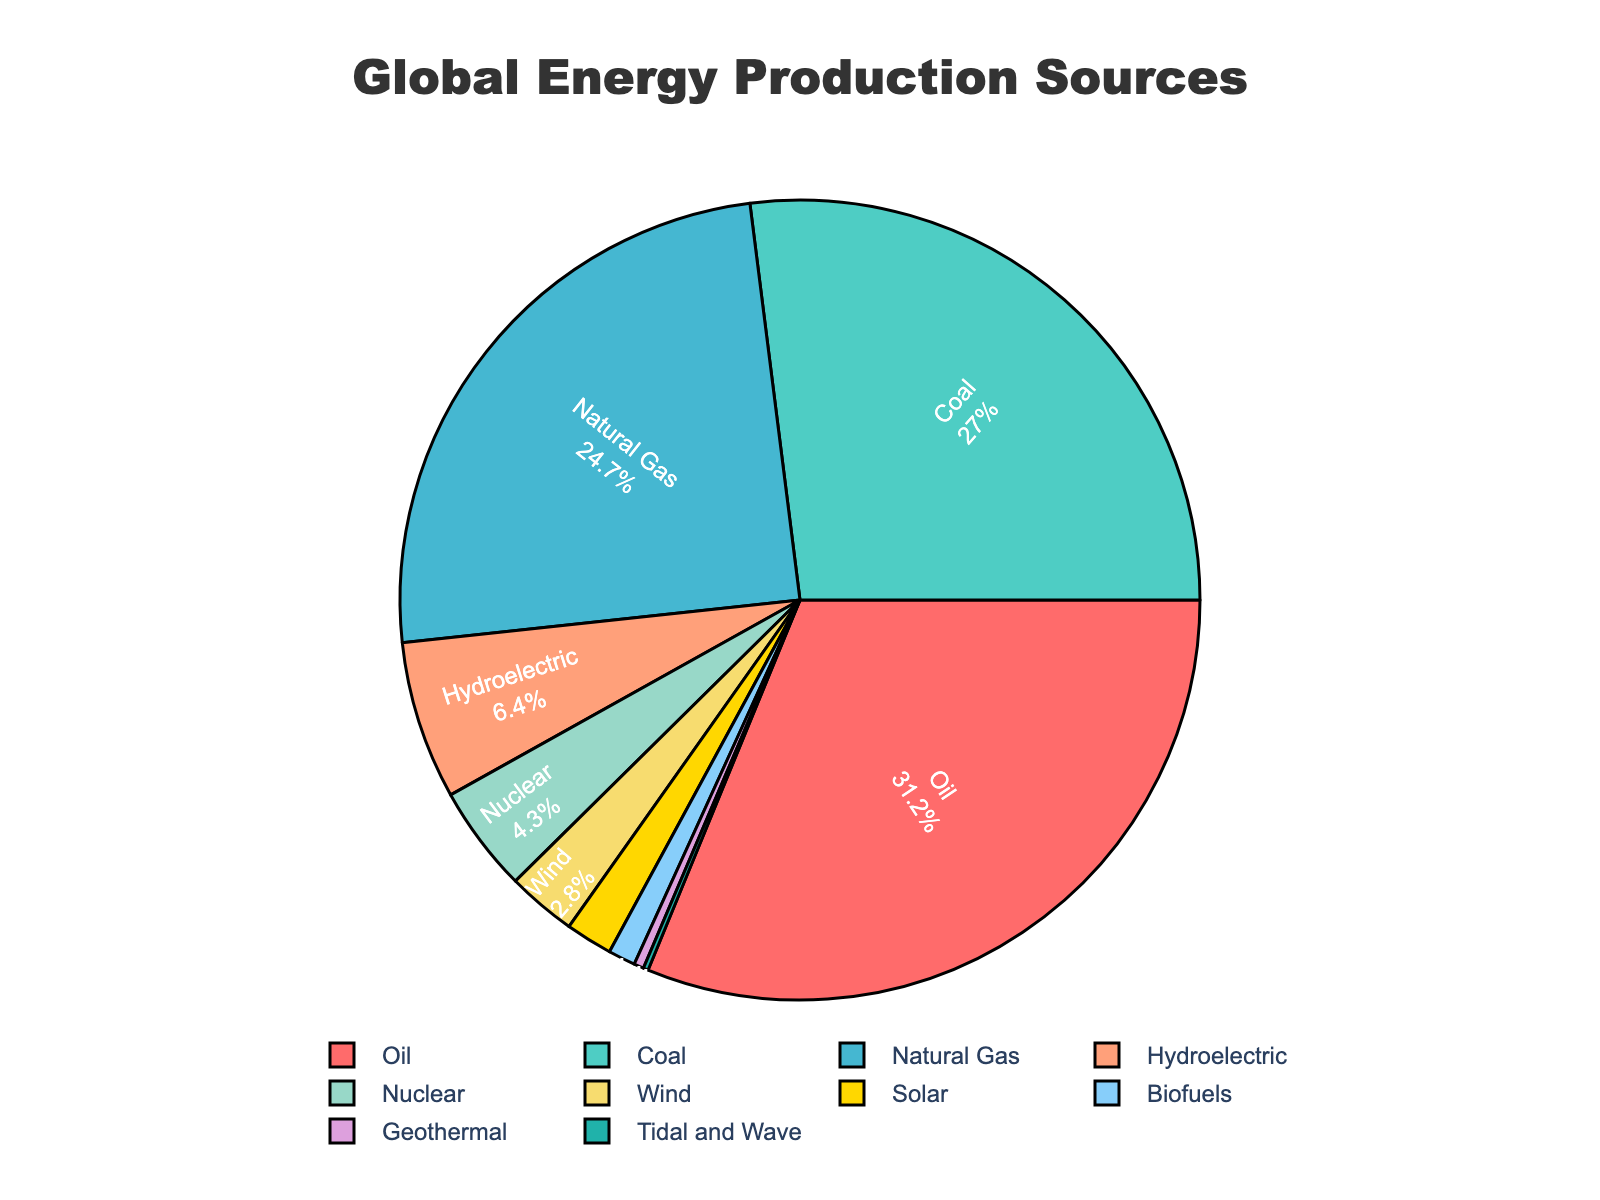What percentage of global energy production comes from non-renewable sources? Non-renewable energy sources include Oil, Coal, Natural Gas, and Nuclear. Their percentages sum up to 31.2 + 27.0 + 24.7 + 4.3 = 87.2%.
Answer: 87.2% Which energy source has the smallest contribution to global energy production? By looking at the percentages, we see that Tidal and Wave has the smallest percentage of 0.2%.
Answer: Tidal and Wave How does the combined percentage of Wind and Solar compare to that of Hydro? The combined percentage of Wind and Solar is 2.8 + 1.9 = 4.7%, while Hydro is 6.4%. Thus, Hydro contributes more.
Answer: Hydro What is the difference in percentage between the largest energy source and the smallest one? The largest energy source is Oil (31.2%) and the smallest is Tidal and Wave (0.2%). The difference is 31.2 - 0.2 = 31%.
Answer: 31% Is the percentage of Nuclear energy greater than that of Biofuels? The percentage of Nuclear energy is 4.3% and Biofuels is 1.1%, so Nuclear is greater.
Answer: Yes If you sum up the percentages of all renewable energy sources, what do you get? Renewable energy sources include Hydroelectric, Wind, Solar, Biofuels, Geothermal, Tidal and Wave. Summing these gives 6.4 + 2.8 + 1.9 + 1.1 + 0.4 + 0.2 = 12.8%.
Answer: 12.8% Which two energy sources have percentages closest to each other and what are they? Natural Gas and Coal have percentages of 24.7% and 27.0%, the difference is 2.3%. Other pairs have larger differences.
Answer: Natural Gas and Coal How many energy sources contribute less than 5% each to global energy production? The sources are Nuclear (4.3%), Wind (2.8%), Solar (1.9%), Biofuels (1.1%), Geothermal (0.4%), and Tidal and Wave (0.2%). This totals 6 sources.
Answer: 6 